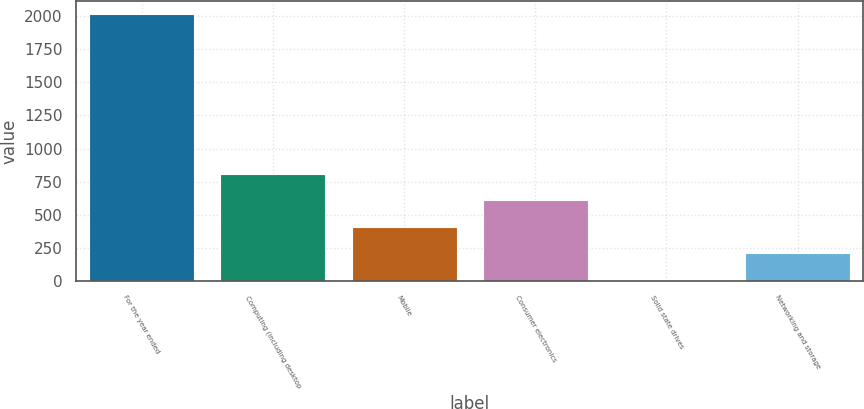Convert chart. <chart><loc_0><loc_0><loc_500><loc_500><bar_chart><fcel>For the year ended<fcel>Computing (including desktop<fcel>Mobile<fcel>Consumer electronics<fcel>Solid state drives<fcel>Networking and storage<nl><fcel>2012<fcel>810.8<fcel>410.4<fcel>610.6<fcel>10<fcel>210.2<nl></chart> 